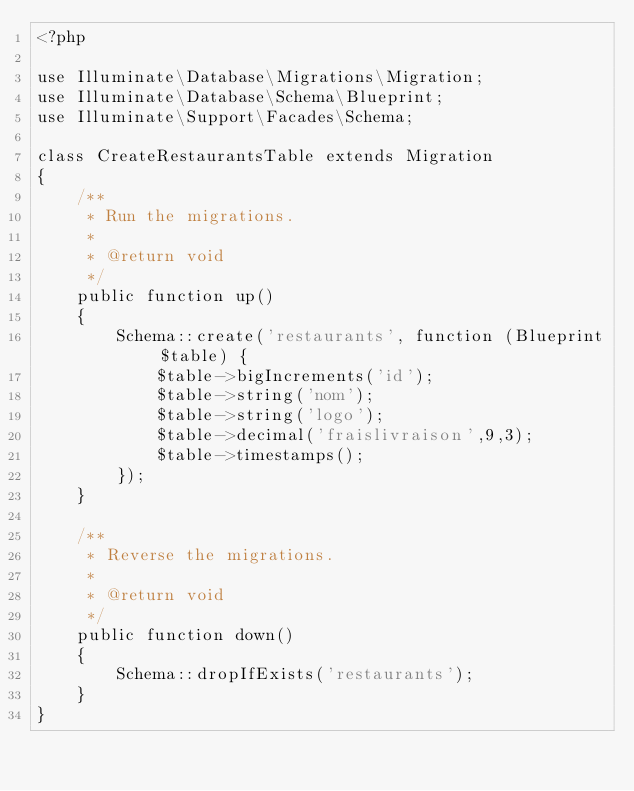<code> <loc_0><loc_0><loc_500><loc_500><_PHP_><?php

use Illuminate\Database\Migrations\Migration;
use Illuminate\Database\Schema\Blueprint;
use Illuminate\Support\Facades\Schema;

class CreateRestaurantsTable extends Migration
{
    /**
     * Run the migrations.
     *
     * @return void
     */
    public function up()
    {
        Schema::create('restaurants', function (Blueprint $table) {
            $table->bigIncrements('id');
            $table->string('nom');
            $table->string('logo');
            $table->decimal('fraislivraison',9,3);
            $table->timestamps();
        });
    }

    /**
     * Reverse the migrations.
     *
     * @return void
     */
    public function down()
    {
        Schema::dropIfExists('restaurants');
    }
}
</code> 